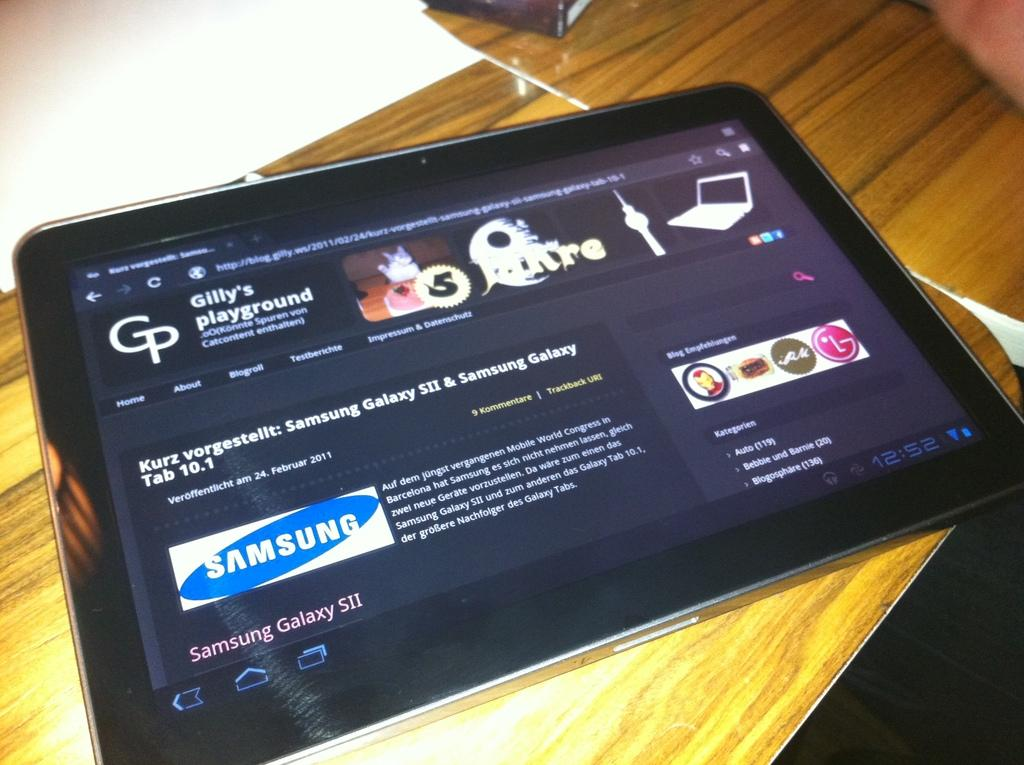What is on the wooden table in the image? There is a tab on the wooden table. What is on the tab? There are white papers on the tab. How would you describe the overall color scheme of the image? The background of the image is dark in color. How many times does the orange kick the ball in the image? There is no orange or ball present in the image, so this question cannot be answered. 